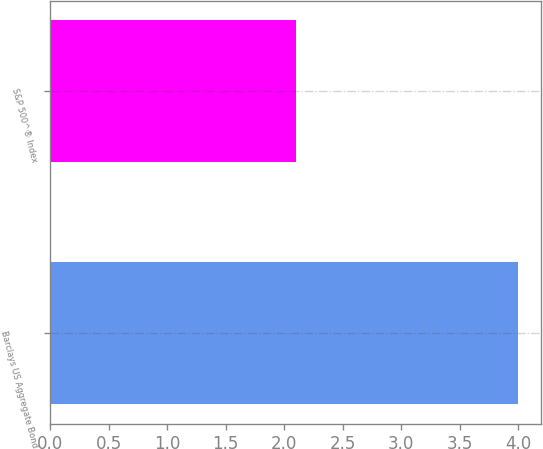Convert chart to OTSL. <chart><loc_0><loc_0><loc_500><loc_500><bar_chart><fcel>Barclays US Aggregate Bond<fcel>S&P 500^® Index<nl><fcel>4<fcel>2.1<nl></chart> 